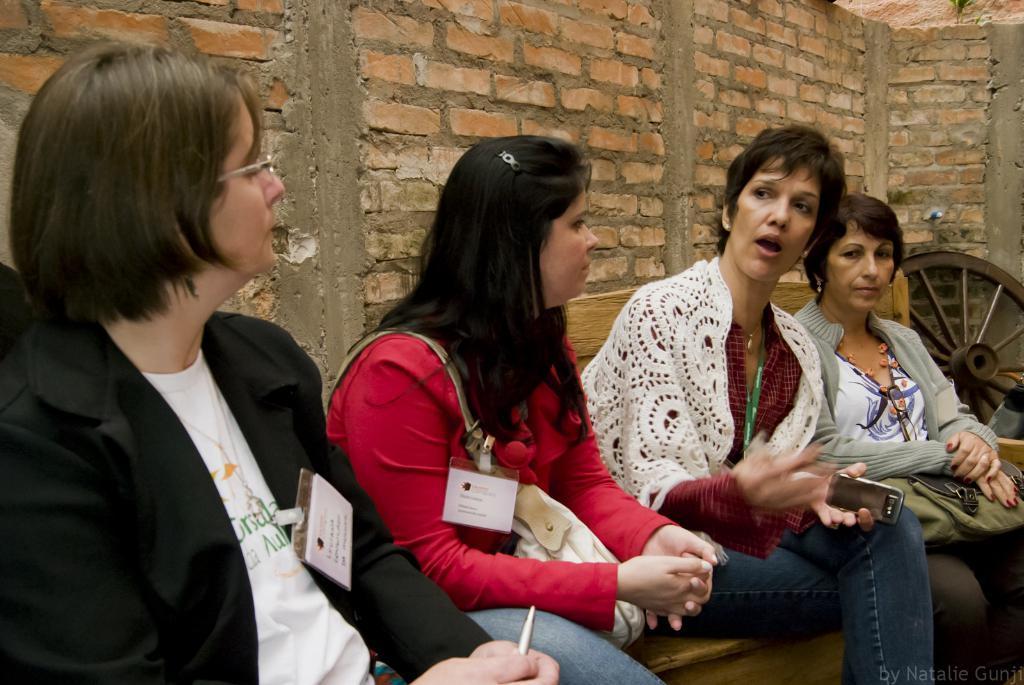In one or two sentences, can you explain what this image depicts? In this image there is an object on the left corner. There are four people sitting on a bench in the foreground. And there is a brick wall in the background. 